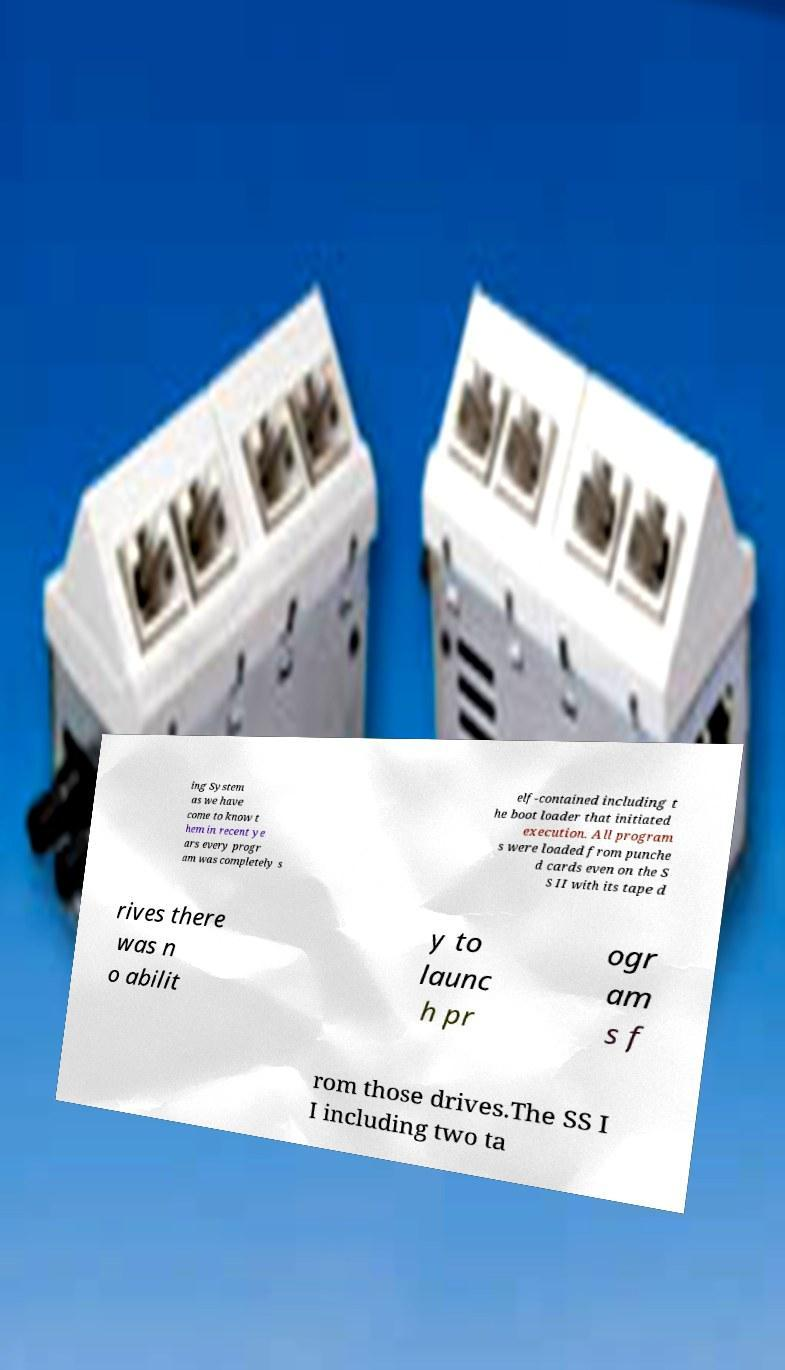There's text embedded in this image that I need extracted. Can you transcribe it verbatim? ing System as we have come to know t hem in recent ye ars every progr am was completely s elf-contained including t he boot loader that initiated execution. All program s were loaded from punche d cards even on the S S II with its tape d rives there was n o abilit y to launc h pr ogr am s f rom those drives.The SS I I including two ta 